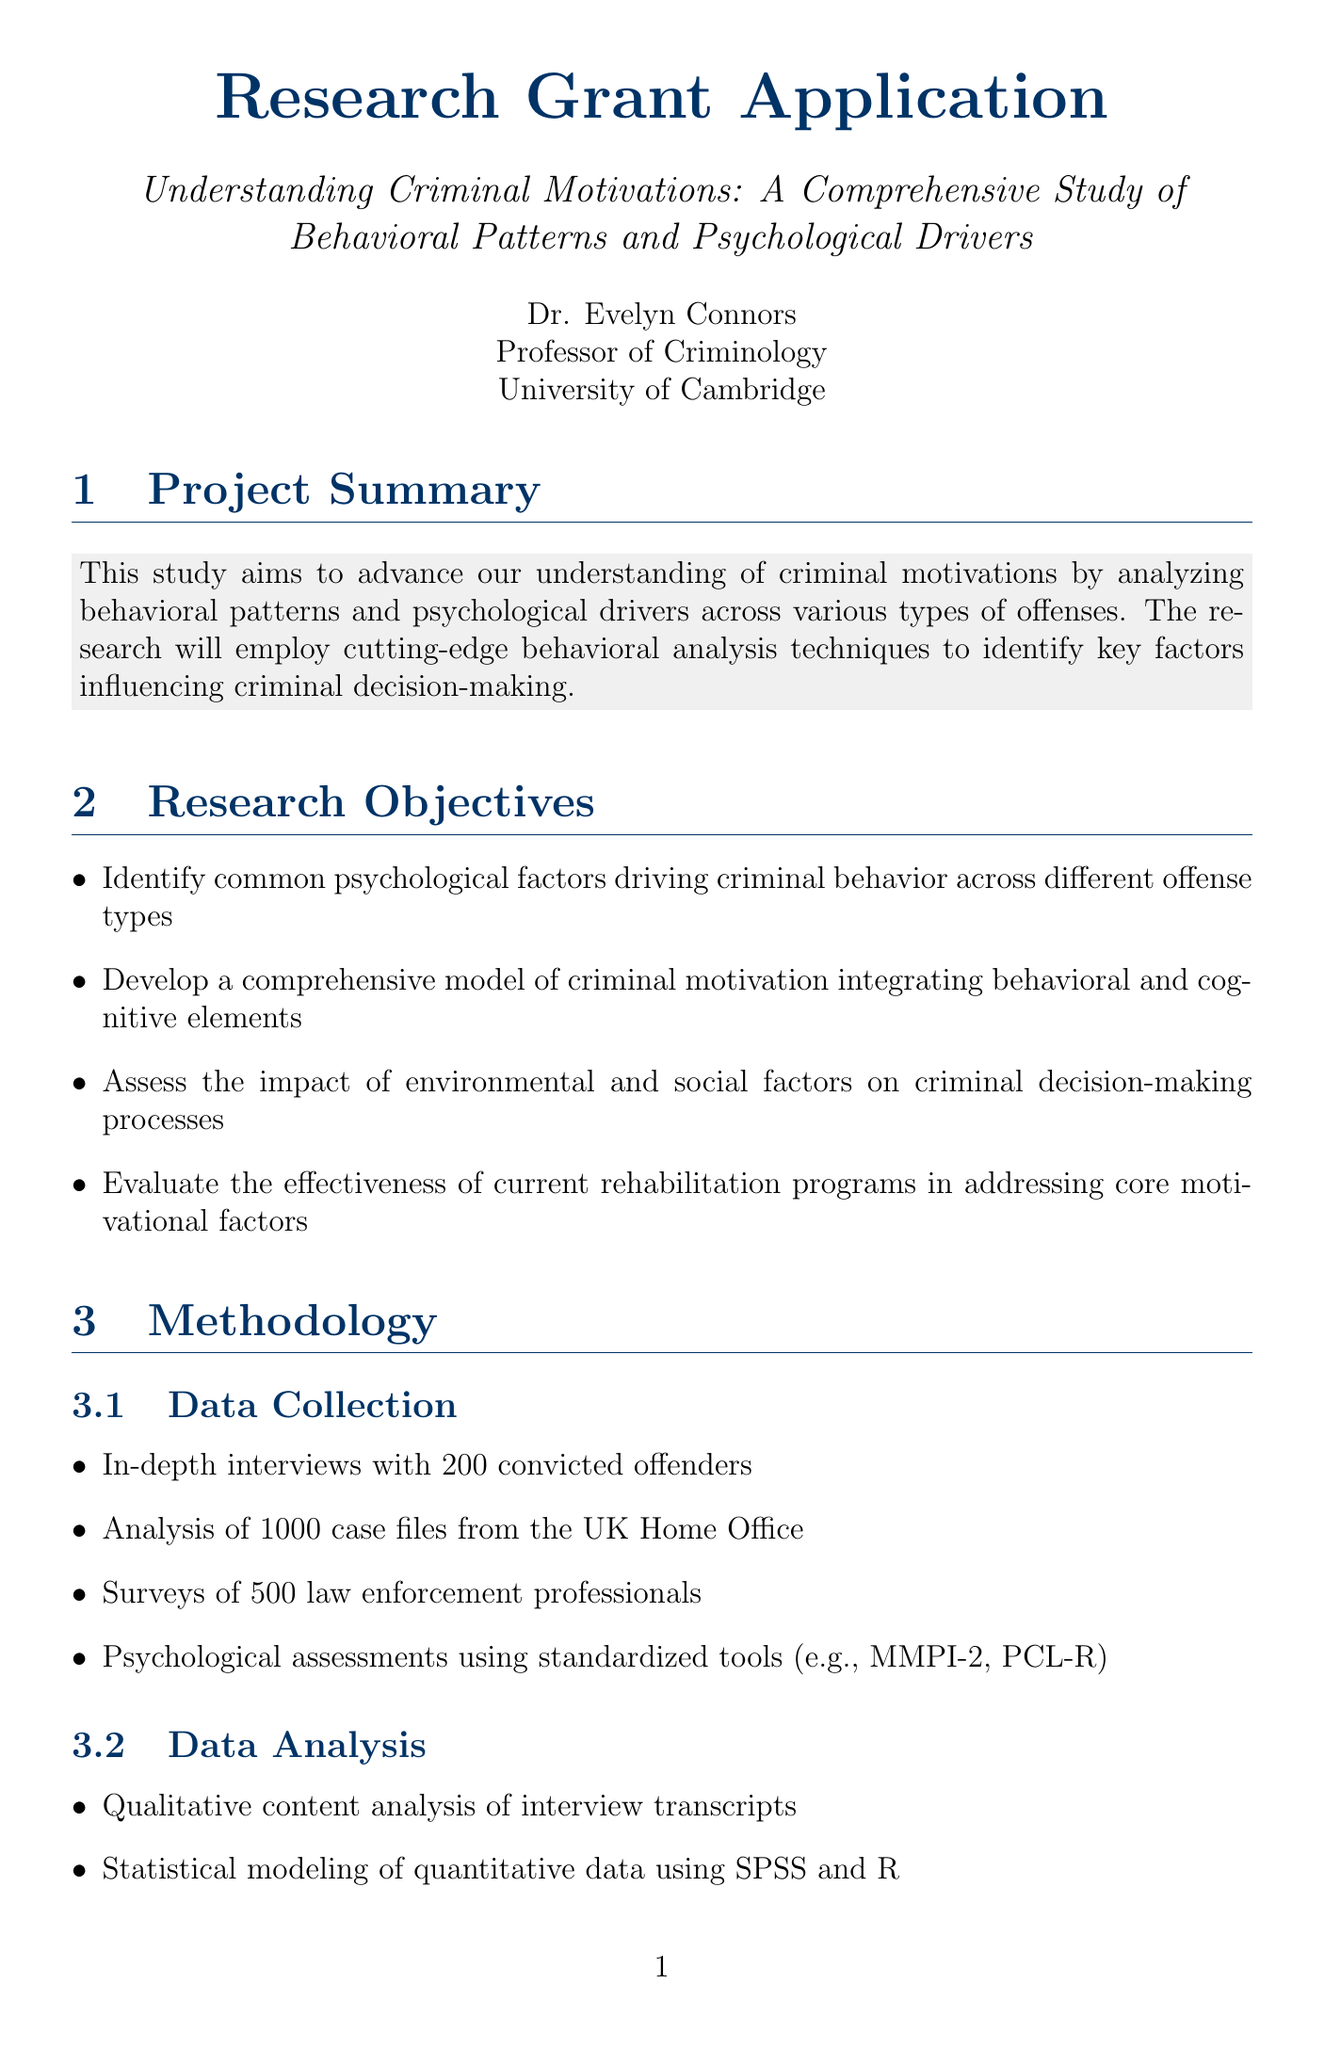what is the total budget amount for the study? The total budget amount is explicitly stated in the budget section of the document.
Answer: 750,000 who is the principal investigator? The principal investigator's name and title are provided at the beginning of the document.
Answer: Dr. Evelyn Connors how many phases are there in the timeline? The timeline section discusses specific phases, and the total can be counted based on the list provided.
Answer: 4 what is a psychological assessment tool used in the data collection? The methodology section lists specific tools used for psychological assessments in the study.
Answer: MMPI-2 what is one expected outcome of the study? The expected outcomes section outlines several expected results from the research.
Answer: Publication of at least 5 peer-reviewed articles in high-impact journals how long will the data collection phase last? The timeline section specifies the duration of each phase, including data collection.
Answer: 18 months which institution will provide access to incarcerated individuals? The collaborating institutions section outlines the roles of various partners in the study.
Answer: HM Prison Service how many law enforcement professionals will be surveyed? The methodology section specifies the number of law enforcement professionals that will be surveyed.
Answer: 500 what percentage of indirect costs is allocated for university overhead? The budget section mentions the specific percentage allocated for indirect costs as described.
Answer: 40% 